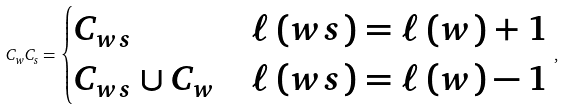Convert formula to latex. <formula><loc_0><loc_0><loc_500><loc_500>C _ { w } C _ { s } = \begin{cases} C _ { w s } & \ell \left ( w s \right ) = \ell \left ( w \right ) + 1 \\ C _ { w s } \cup C _ { w } & \ell \left ( w s \right ) = \ell \left ( w \right ) - 1 \end{cases} \, ,</formula> 